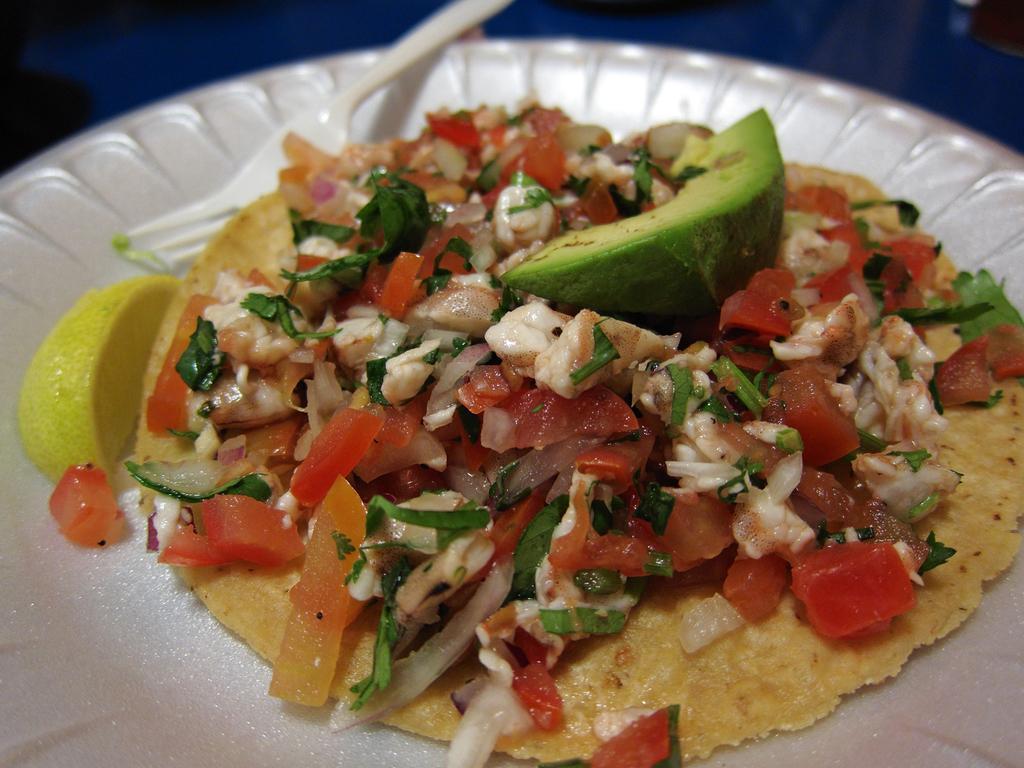In one or two sentences, can you explain what this image depicts? In this picture I can see a white color plate, on which there is food which is of white, green, red and cream color and I see a piece of lemon. I can also see a fork on the plate. 